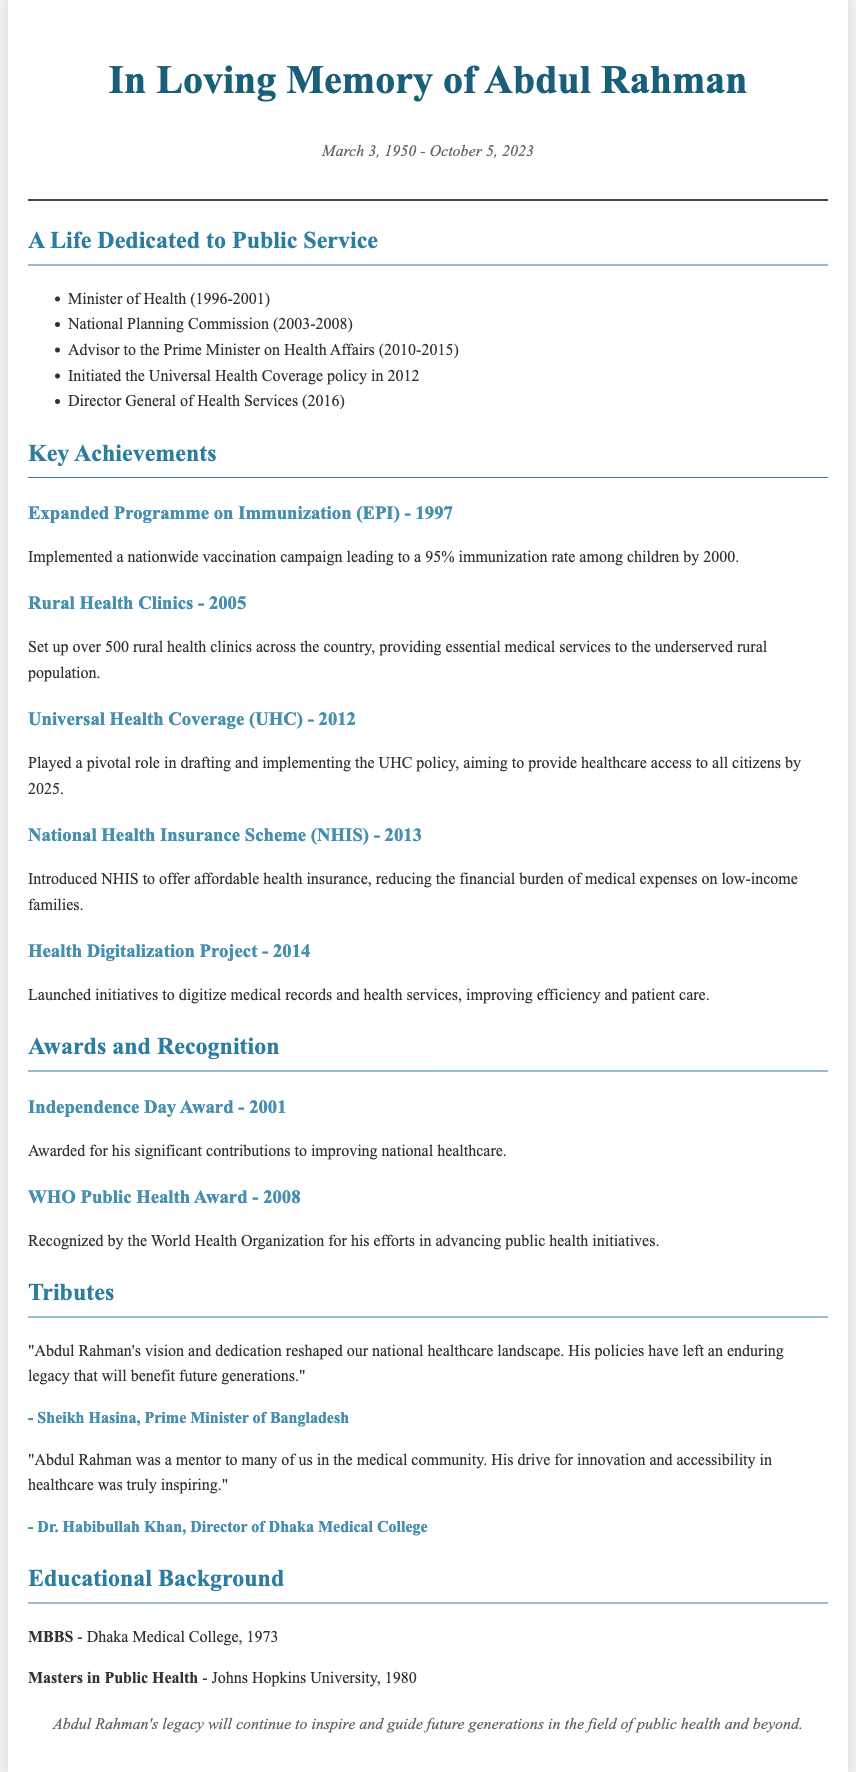what were the life dates of Abdul Rahman? The life dates of Abdul Rahman are specified at the beginning of the document, which state he was born on March 3, 1950, and passed away on October 5, 2023.
Answer: March 3, 1950 - October 5, 2023 which recognition did he receive in 2001? The document mentions that in 2001, Abdul Rahman was awarded the Independence Day Award for his contributions to improving national healthcare.
Answer: Independence Day Award what position did Abdul Rahman hold from 1996 to 2001? The document lists his roles, indicating he served as the Minister of Health during that time frame.
Answer: Minister of Health what initiative did he launch in 2012? The document highlights his involvement in the Universal Health Coverage policy in 2012.
Answer: Universal Health Coverage policy how many rural health clinics were established in 2005? According to the achievements section, more than 500 rural health clinics were set up to aid the underserved population.
Answer: over 500 who described Abdul Rahman as a mentor to many in the medical community? The tribute from Dr. Habibullah Khan states he was a mentor to many in the medical community.
Answer: Dr. Habibullah Khan what was Abdul Rahman's highest educational qualification? The document states he earned a Masters in Public Health from Johns Hopkins University in 1980.
Answer: Masters in Public Health which award did he receive from the World Health Organization? The document specifies the WHO Public Health Award, which he received in 2008 for his public health initiatives.
Answer: WHO Public Health Award what was a key feature of the Health Digitalization Project launched in 2014? The document mentions it aimed to digitize medical records and health services to improve efficiency and patient care.
Answer: digitize medical records and health services 